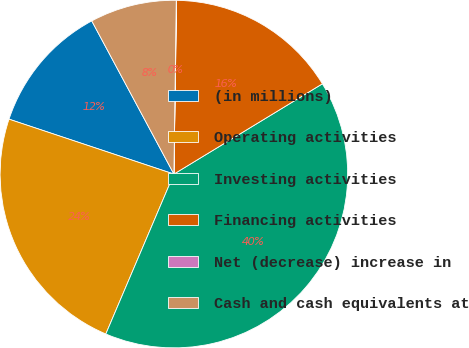<chart> <loc_0><loc_0><loc_500><loc_500><pie_chart><fcel>(in millions)<fcel>Operating activities<fcel>Investing activities<fcel>Financing activities<fcel>Net (decrease) increase in<fcel>Cash and cash equivalents at<nl><fcel>12.05%<fcel>23.71%<fcel>40.1%<fcel>16.06%<fcel>0.03%<fcel>8.05%<nl></chart> 